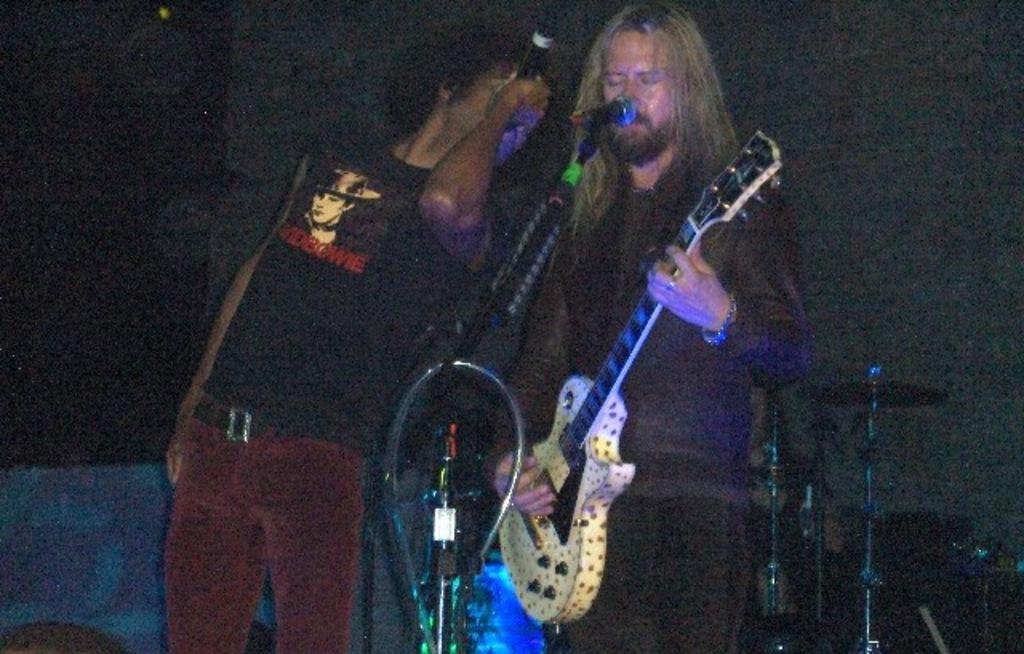In one or two sentences, can you explain what this image depicts? As we can see in the image there are two persons. The person on the left is holding mike in his hand and the person on the right is holding guitar in his hand. 